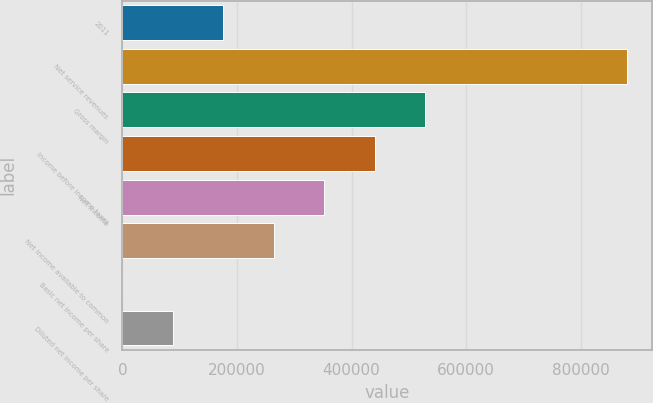<chart> <loc_0><loc_0><loc_500><loc_500><bar_chart><fcel>2011<fcel>Net service revenues<fcel>Gross margin<fcel>Income before income taxes<fcel>Net income<fcel>Net income available to common<fcel>Basic net income per share<fcel>Diluted net income per share<nl><fcel>176174<fcel>880869<fcel>528521<fcel>440435<fcel>352348<fcel>264261<fcel>0.18<fcel>88087.1<nl></chart> 